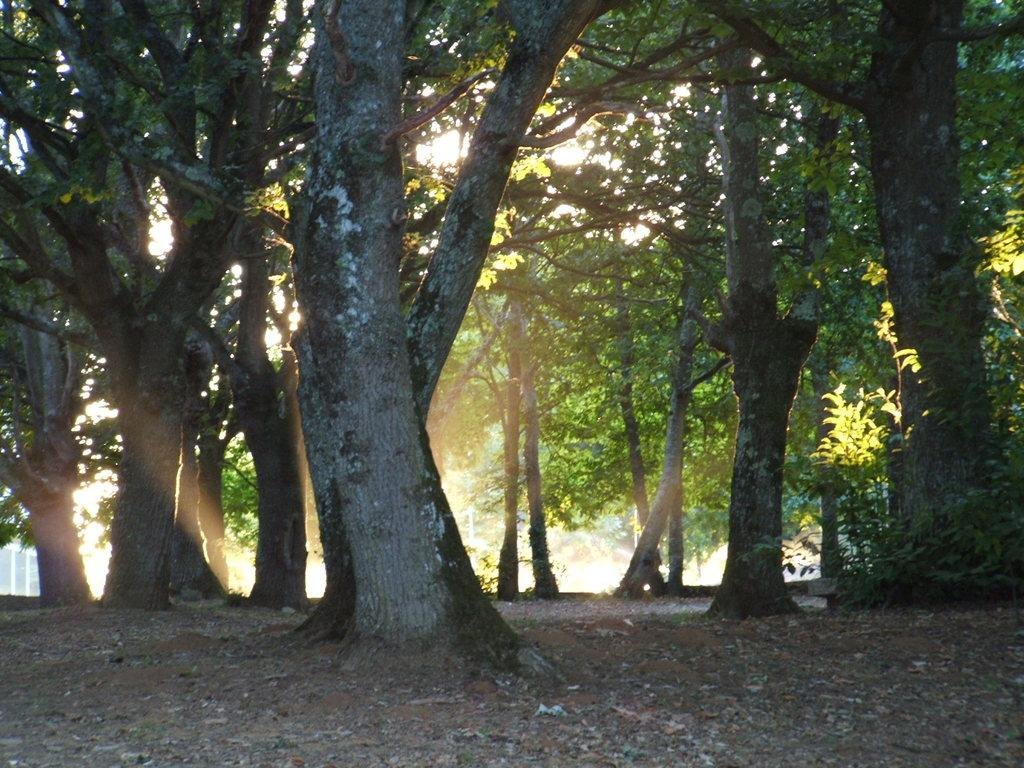What type of vegetation is present on the ground in the image? There are trees and plants on the ground in the image. What else can be found on the ground besides vegetation? There are stones on the ground in the image. What color is the background of the image? The background of the image is white in color. Where is the mailbox located in the image? There is no mailbox present in the image. What type of boats can be seen sailing in the background of the image? There are no boats visible in the image, and the background is white in color. 